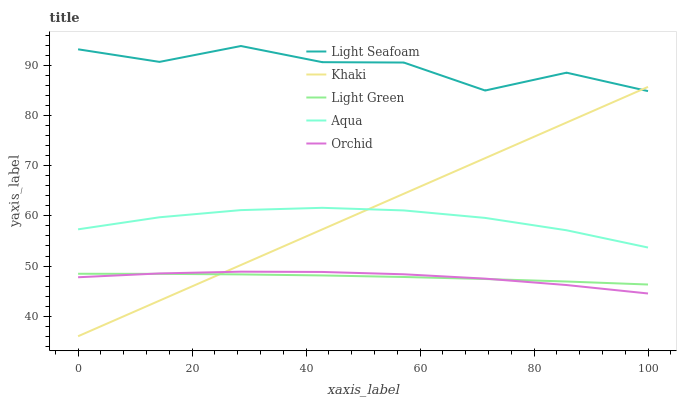Does Orchid have the minimum area under the curve?
Answer yes or no. Yes. Does Light Seafoam have the maximum area under the curve?
Answer yes or no. Yes. Does Aqua have the minimum area under the curve?
Answer yes or no. No. Does Aqua have the maximum area under the curve?
Answer yes or no. No. Is Khaki the smoothest?
Answer yes or no. Yes. Is Light Seafoam the roughest?
Answer yes or no. Yes. Is Aqua the smoothest?
Answer yes or no. No. Is Aqua the roughest?
Answer yes or no. No. Does Aqua have the lowest value?
Answer yes or no. No. Does Aqua have the highest value?
Answer yes or no. No. Is Orchid less than Light Seafoam?
Answer yes or no. Yes. Is Aqua greater than Orchid?
Answer yes or no. Yes. Does Orchid intersect Light Seafoam?
Answer yes or no. No. 